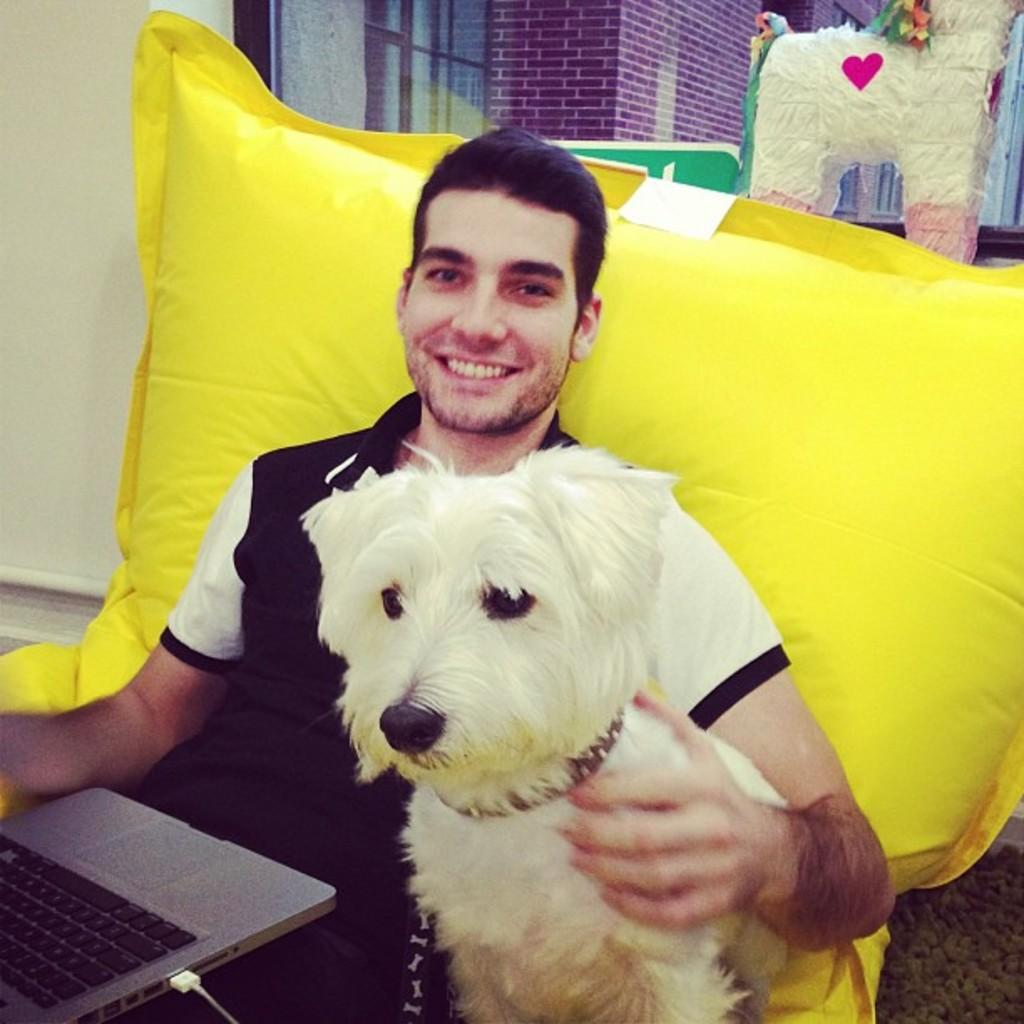Who is present in the image? There is a man in the image. What is the man doing in the image? The man is smiling in the image. What is the man holding in the image? The man is holding a dog and a laptop in the image. What other objects can be seen in the image? There is a pillow and a toy in the image. What can be seen in the background of the image? There is a wall, a window, and a building visible through the window in the image. What type of help can be seen being provided in the image? There is no indication of help being provided in the image; it simply shows a man holding a dog and a laptop. What type of meeting is taking place in the image? There is no meeting taking place in the image; it only shows a man with a dog and a laptop. 